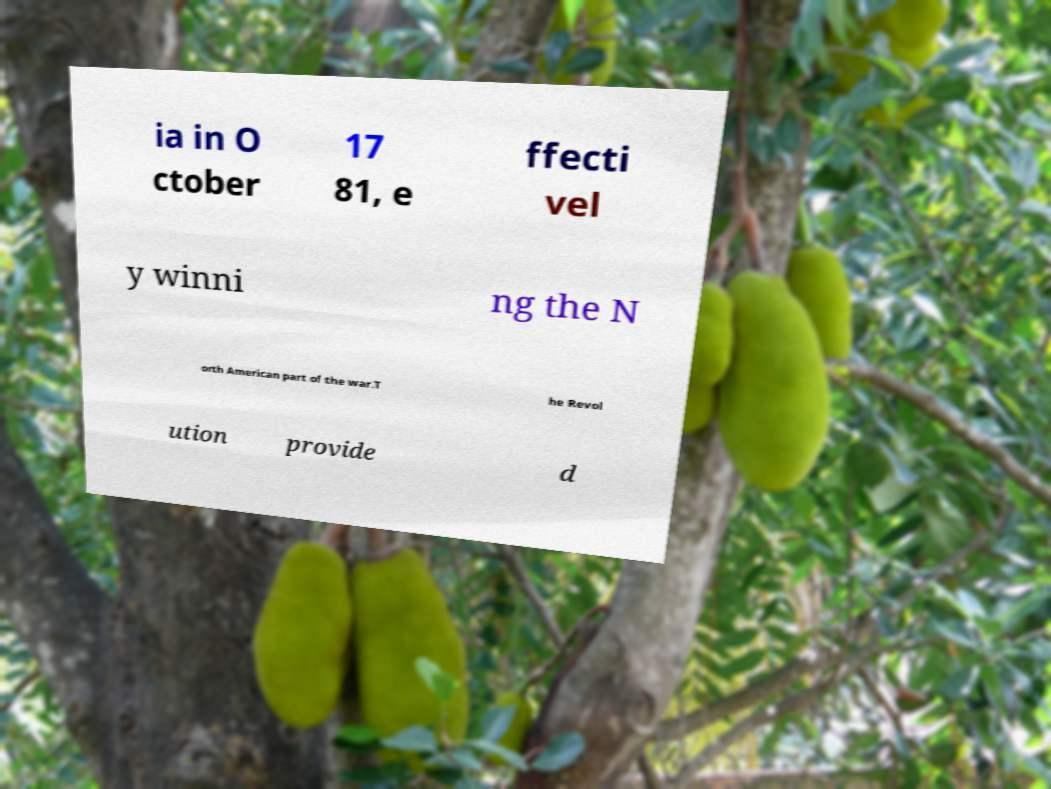Can you accurately transcribe the text from the provided image for me? ia in O ctober 17 81, e ffecti vel y winni ng the N orth American part of the war.T he Revol ution provide d 